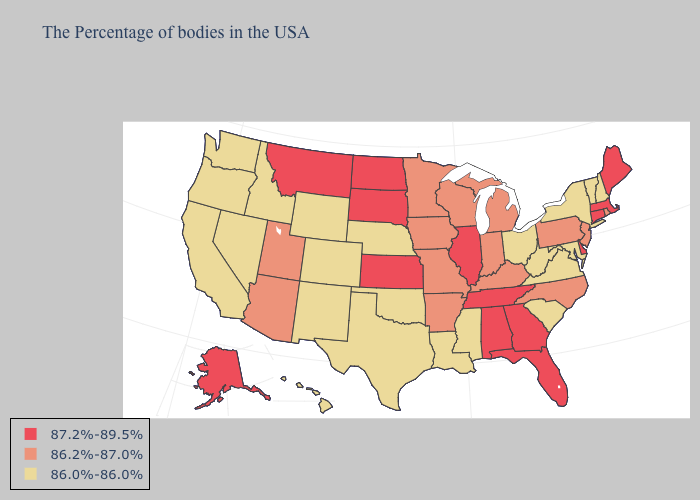What is the highest value in states that border Vermont?
Keep it brief. 87.2%-89.5%. Name the states that have a value in the range 86.2%-87.0%?
Answer briefly. Rhode Island, New Jersey, Pennsylvania, North Carolina, Michigan, Kentucky, Indiana, Wisconsin, Missouri, Arkansas, Minnesota, Iowa, Utah, Arizona. What is the highest value in the USA?
Quick response, please. 87.2%-89.5%. Name the states that have a value in the range 86.2%-87.0%?
Answer briefly. Rhode Island, New Jersey, Pennsylvania, North Carolina, Michigan, Kentucky, Indiana, Wisconsin, Missouri, Arkansas, Minnesota, Iowa, Utah, Arizona. Does the first symbol in the legend represent the smallest category?
Write a very short answer. No. Name the states that have a value in the range 86.0%-86.0%?
Concise answer only. New Hampshire, Vermont, New York, Maryland, Virginia, South Carolina, West Virginia, Ohio, Mississippi, Louisiana, Nebraska, Oklahoma, Texas, Wyoming, Colorado, New Mexico, Idaho, Nevada, California, Washington, Oregon, Hawaii. Does the first symbol in the legend represent the smallest category?
Answer briefly. No. Does Vermont have a lower value than California?
Write a very short answer. No. What is the value of Colorado?
Quick response, please. 86.0%-86.0%. Is the legend a continuous bar?
Quick response, please. No. Which states hav the highest value in the MidWest?
Give a very brief answer. Illinois, Kansas, South Dakota, North Dakota. What is the value of Mississippi?
Give a very brief answer. 86.0%-86.0%. How many symbols are there in the legend?
Short answer required. 3. Name the states that have a value in the range 86.0%-86.0%?
Answer briefly. New Hampshire, Vermont, New York, Maryland, Virginia, South Carolina, West Virginia, Ohio, Mississippi, Louisiana, Nebraska, Oklahoma, Texas, Wyoming, Colorado, New Mexico, Idaho, Nevada, California, Washington, Oregon, Hawaii. Name the states that have a value in the range 87.2%-89.5%?
Answer briefly. Maine, Massachusetts, Connecticut, Delaware, Florida, Georgia, Alabama, Tennessee, Illinois, Kansas, South Dakota, North Dakota, Montana, Alaska. 